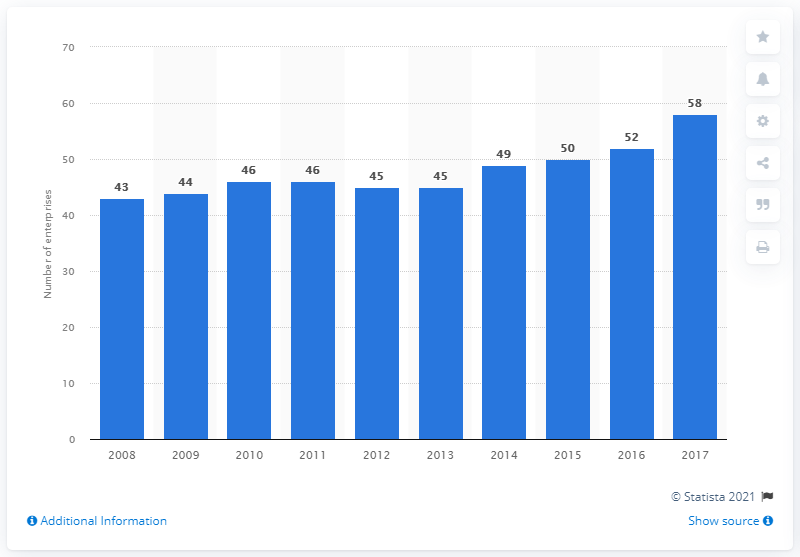Highlight a few significant elements in this photo. In 2017, there were 58 enterprises in Cyprus that produced grape wine. 